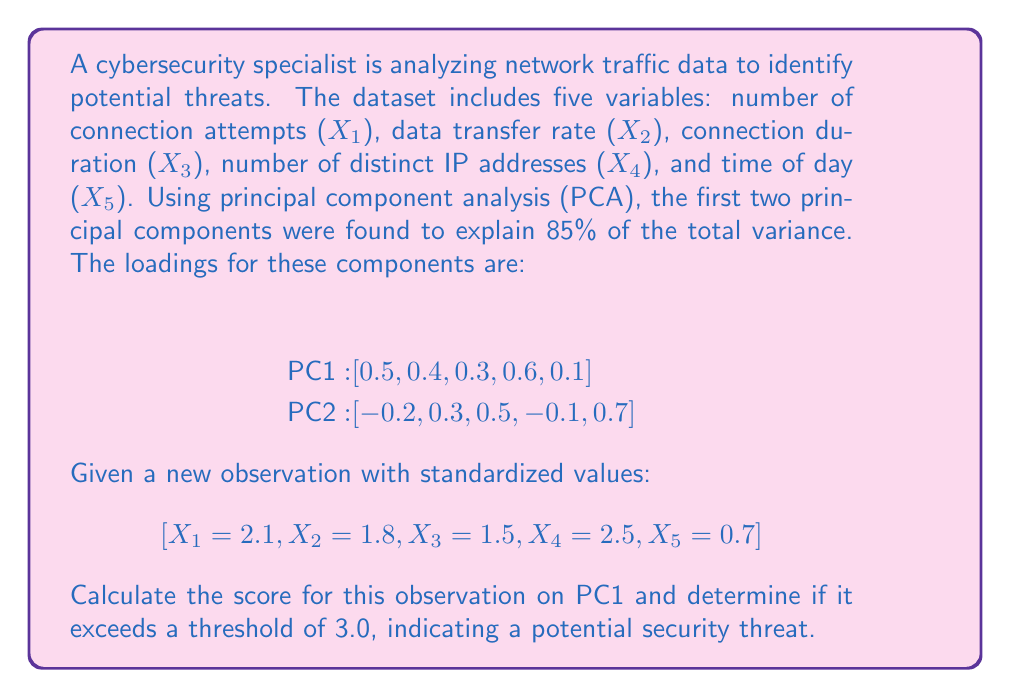Could you help me with this problem? To solve this problem, we need to calculate the score for the new observation on PC1 using the given loadings and standardized values. The process is as follows:

1. The score for an observation on a principal component is calculated by taking the dot product of the standardized observation values and the component loadings.

2. For PC1, the loadings are [0.5, 0.4, 0.3, 0.6, 0.1].

3. The standardized observation values are [2.1, 1.8, 1.5, 2.5, 0.7].

4. Calculate the dot product:

   $$\text{PC1 Score} = (0.5 \times 2.1) + (0.4 \times 1.8) + (0.3 \times 1.5) + (0.6 \times 2.5) + (0.1 \times 0.7)$$

5. Compute each term:
   $$\begin{align*}
   0.5 \times 2.1 &= 1.05 \\
   0.4 \times 1.8 &= 0.72 \\
   0.3 \times 1.5 &= 0.45 \\
   0.6 \times 2.5 &= 1.50 \\
   0.1 \times 0.7 &= 0.07
   \end{align*}$$

6. Sum the results:
   $$\text{PC1 Score} = 1.05 + 0.72 + 0.45 + 1.50 + 0.07 = 3.79$$

7. Compare the calculated score (3.79) to the threshold (3.0):
   $$3.79 > 3.0$$

The PC1 score for this observation (3.79) exceeds the threshold of 3.0, indicating a potential security threat.
Answer: The PC1 score is 3.79, which exceeds the threshold of 3.0, indicating a potential security threat. 